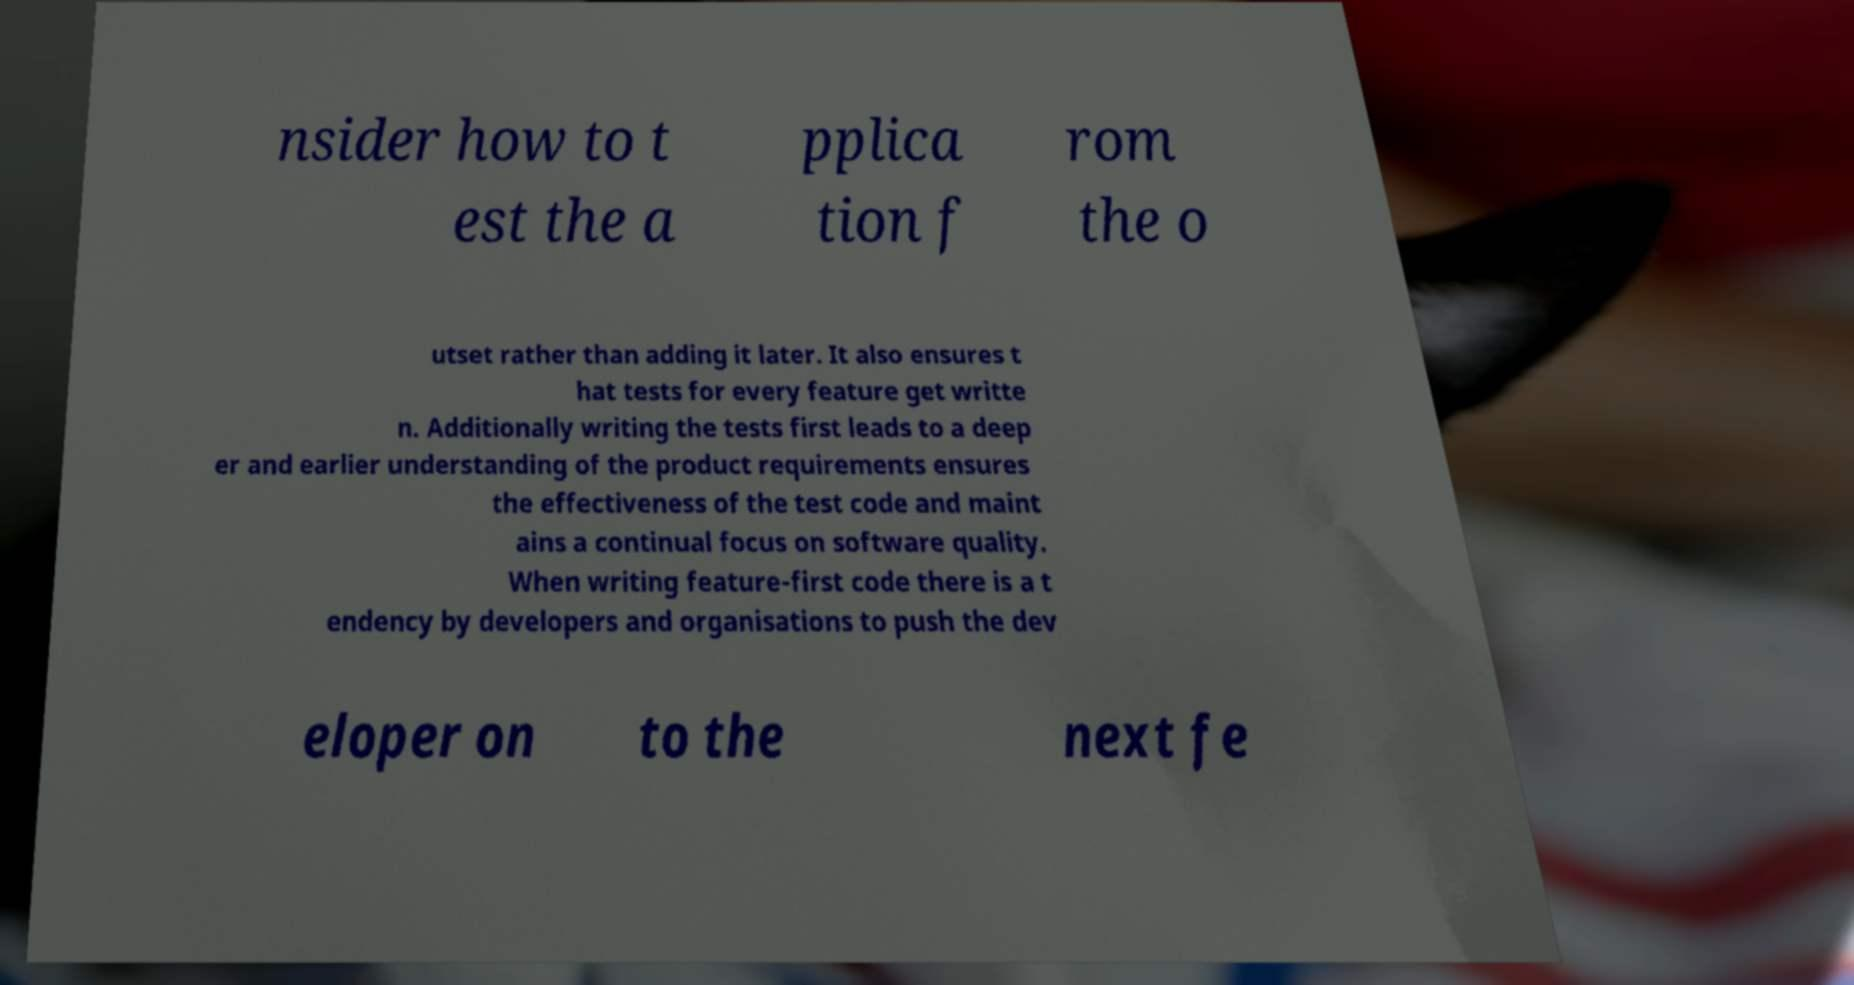Can you accurately transcribe the text from the provided image for me? nsider how to t est the a pplica tion f rom the o utset rather than adding it later. It also ensures t hat tests for every feature get writte n. Additionally writing the tests first leads to a deep er and earlier understanding of the product requirements ensures the effectiveness of the test code and maint ains a continual focus on software quality. When writing feature-first code there is a t endency by developers and organisations to push the dev eloper on to the next fe 